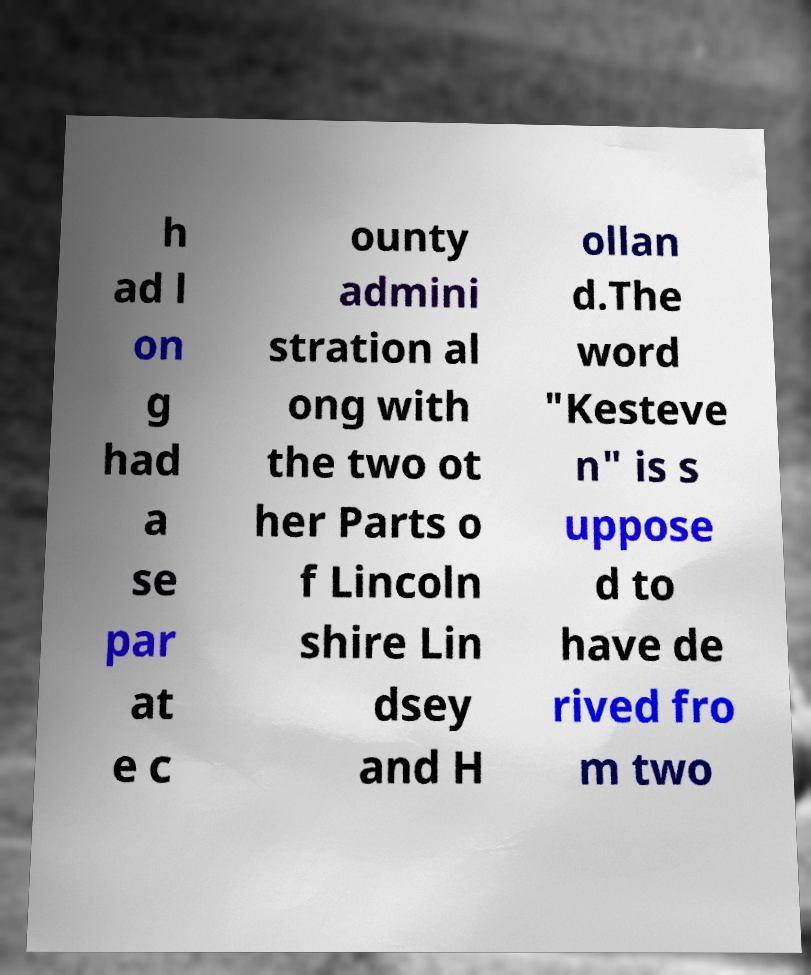Please identify and transcribe the text found in this image. h ad l on g had a se par at e c ounty admini stration al ong with the two ot her Parts o f Lincoln shire Lin dsey and H ollan d.The word "Kesteve n" is s uppose d to have de rived fro m two 